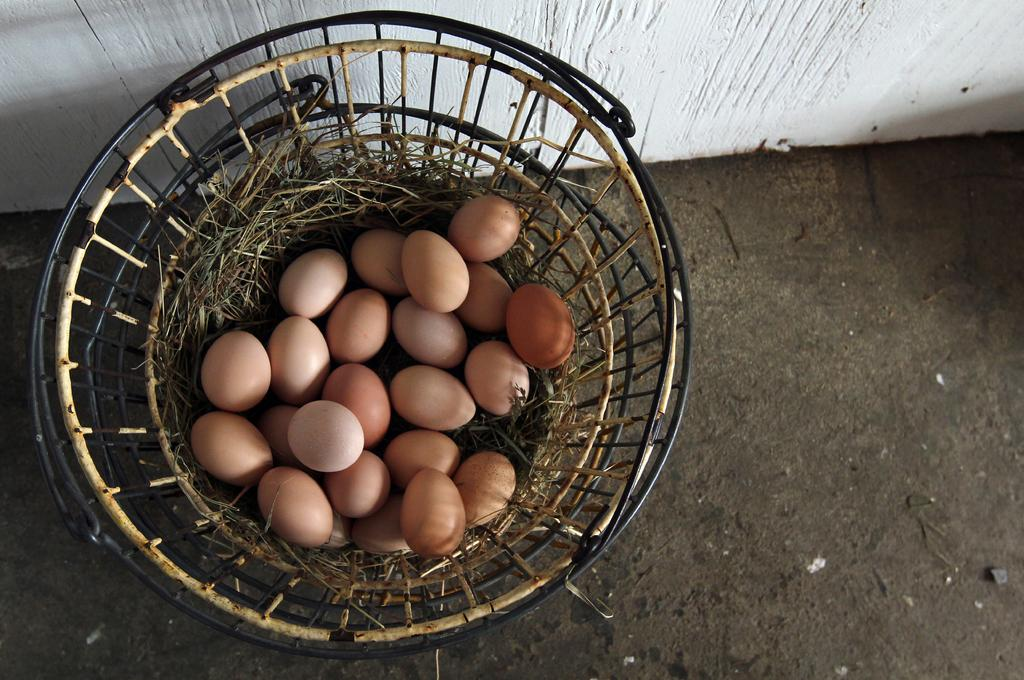What object is present in the image that can hold items? There is a basket in the image. What is inside the basket? The basket contains grass. Are there any additional items on the grass in the basket? Yes, there are eggs on the grass in the basket. Where is the basket located? The basket is on the land. What can be seen at the top of the image? There is a wall at the top of the image. What type of veil can be seen covering the eggs in the image? There is no veil present in the image; the eggs are on the grass in the basket. 